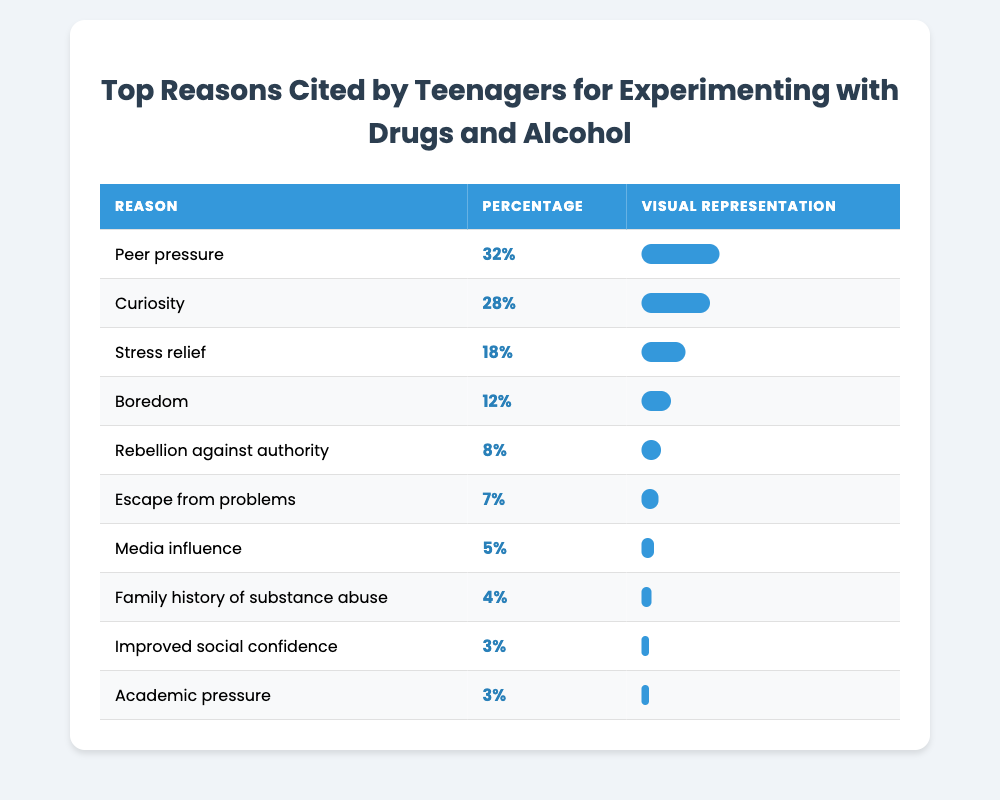What is the most cited reason for teenagers experimenting with drugs and alcohol? The table lists the reasons in descending order of percentage. The first item is "Peer pressure," which has the highest percentage of 32%.
Answer: Peer pressure What percentage of teenagers cited curiosity as a reason for experimenting with drugs and alcohol? By referring to the table, "Curiosity" appears with a percentage of 28%.
Answer: 28% How many reasons are cited by teenagers for experimenting with drugs and alcohol? The table lists 10 different reasons, each associated with a percentage.
Answer: 10 What is the difference in percentage between stress relief and boredom as reasons? The percentage for "Stress relief" is 18% and for "Boredom" it is 12%. The difference is calculated as 18% - 12% = 6%.
Answer: 6% True or False: More than half of the teenagers cited peer pressure as their reason for experimenting. Since peer pressure has a percentage of 32%, it is below half (which would be 50%). Therefore, the statement is false.
Answer: False What percentage of teenagers reported escape from problems as a reason compared to family history of substance abuse? "Escape from problems" has 7% while "Family history of substance abuse" has 4%. The difference is 7% - 4% = 3%.
Answer: 3% If we sum the percentages for rebellion against authority and improved social confidence, what do we get? "Rebellion against authority" has 8% and "Improved social confidence" has 3%. Summing these gives us 8% + 3% = 11%.
Answer: 11% What is the average percentage of all reasons listed for experimenting with drugs and alcohol? To find the average, we sum all the percentages: 32 + 28 + 18 + 12 + 8 + 7 + 5 + 4 + 3 + 3 = 120. There are 10 reasons, so the average is 120/10 = 12%.
Answer: 12% Which reason had the least percentage according to the table? The reason with the least percentage is "Improved social confidence" and "Academic pressure," both at 3%.
Answer: Improved social confidence (or Academic pressure) How many reasons had percentages greater than 10%? By examining the table, the reasons above 10% are: "Peer pressure" (32%), "Curiosity" (28%), "Stress relief" (18%), and "Boredom" (12%). This accounts for 4 reasons in total.
Answer: 4 